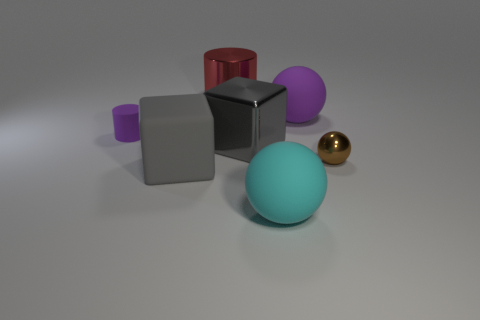What is the material of the big thing that is the same color as the metallic cube?
Provide a short and direct response. Rubber. There is a block on the left side of the large red metallic object; what material is it?
Your answer should be compact. Rubber. The matte ball that is the same color as the matte cylinder is what size?
Offer a terse response. Large. Do the big rubber sphere behind the cyan rubber ball and the small thing to the left of the cyan thing have the same color?
Your answer should be very brief. Yes. How many things are either matte cylinders or shiny cylinders?
Provide a short and direct response. 2. What number of other things are the same shape as the tiny purple rubber object?
Provide a short and direct response. 1. Is the material of the tiny thing that is left of the big red shiny thing the same as the large cube in front of the tiny metallic object?
Your answer should be compact. Yes. What is the shape of the large rubber object that is both to the right of the red metal object and behind the large cyan rubber ball?
Ensure brevity in your answer.  Sphere. What material is the big thing that is both left of the shiny block and behind the metal block?
Offer a very short reply. Metal. What is the shape of the large gray thing that is made of the same material as the large cyan ball?
Provide a short and direct response. Cube. 